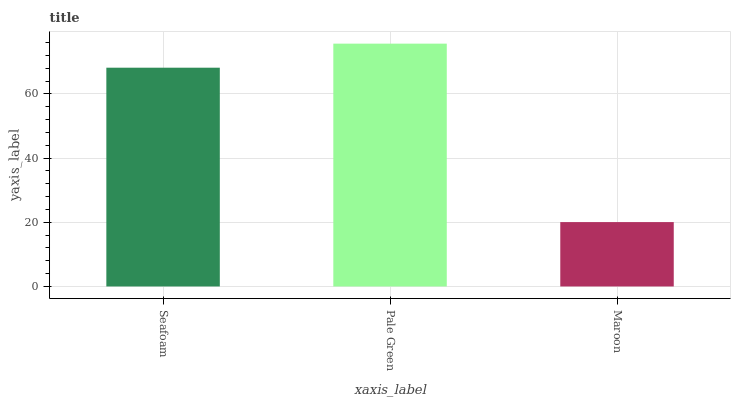Is Maroon the minimum?
Answer yes or no. Yes. Is Pale Green the maximum?
Answer yes or no. Yes. Is Pale Green the minimum?
Answer yes or no. No. Is Maroon the maximum?
Answer yes or no. No. Is Pale Green greater than Maroon?
Answer yes or no. Yes. Is Maroon less than Pale Green?
Answer yes or no. Yes. Is Maroon greater than Pale Green?
Answer yes or no. No. Is Pale Green less than Maroon?
Answer yes or no. No. Is Seafoam the high median?
Answer yes or no. Yes. Is Seafoam the low median?
Answer yes or no. Yes. Is Pale Green the high median?
Answer yes or no. No. Is Maroon the low median?
Answer yes or no. No. 